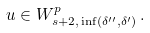<formula> <loc_0><loc_0><loc_500><loc_500>u \in W ^ { p } _ { s + 2 , \, \inf ( \delta ^ { \prime \prime } , \delta ^ { \prime } ) } \, .</formula> 